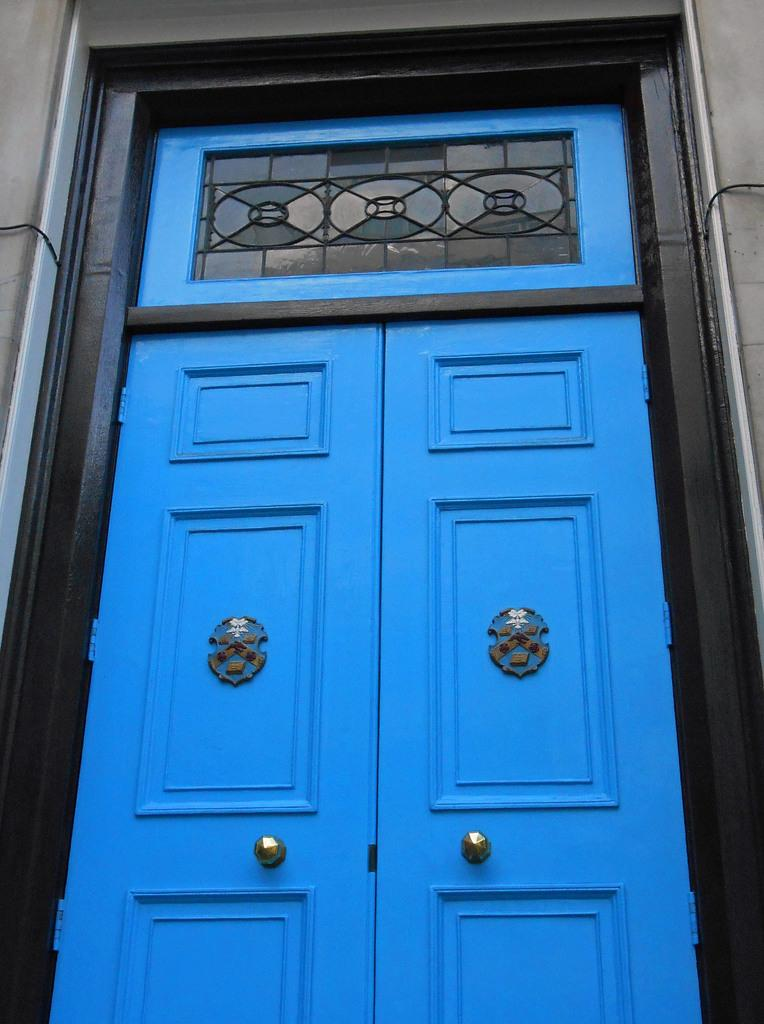What color are the doors in the image? The doors in the image are blue. What type of structure is visible in the image? There is a building in the image. How many elbows can be seen in the image? There are no elbows visible in the image. What type of room is depicted in the image? The image does not show a room; it only shows the exterior of a building with blue doors. 